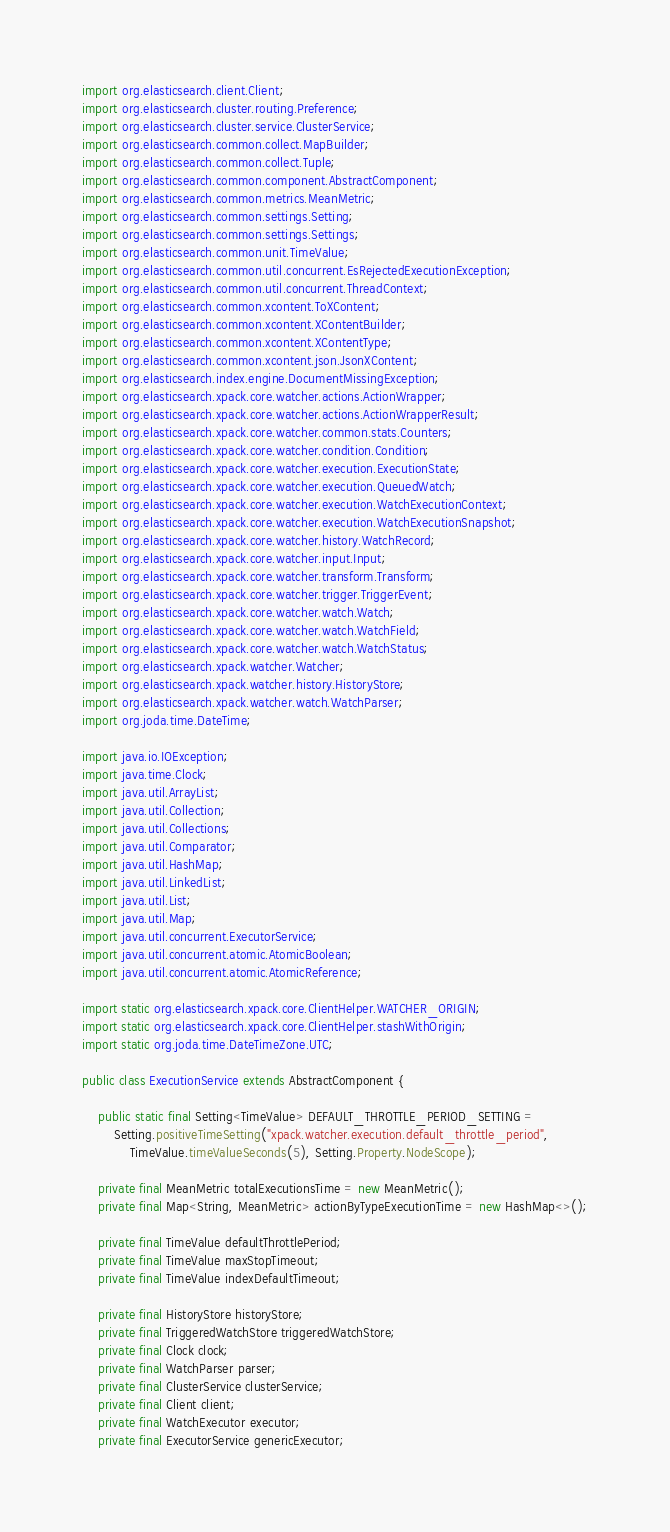Convert code to text. <code><loc_0><loc_0><loc_500><loc_500><_Java_>import org.elasticsearch.client.Client;
import org.elasticsearch.cluster.routing.Preference;
import org.elasticsearch.cluster.service.ClusterService;
import org.elasticsearch.common.collect.MapBuilder;
import org.elasticsearch.common.collect.Tuple;
import org.elasticsearch.common.component.AbstractComponent;
import org.elasticsearch.common.metrics.MeanMetric;
import org.elasticsearch.common.settings.Setting;
import org.elasticsearch.common.settings.Settings;
import org.elasticsearch.common.unit.TimeValue;
import org.elasticsearch.common.util.concurrent.EsRejectedExecutionException;
import org.elasticsearch.common.util.concurrent.ThreadContext;
import org.elasticsearch.common.xcontent.ToXContent;
import org.elasticsearch.common.xcontent.XContentBuilder;
import org.elasticsearch.common.xcontent.XContentType;
import org.elasticsearch.common.xcontent.json.JsonXContent;
import org.elasticsearch.index.engine.DocumentMissingException;
import org.elasticsearch.xpack.core.watcher.actions.ActionWrapper;
import org.elasticsearch.xpack.core.watcher.actions.ActionWrapperResult;
import org.elasticsearch.xpack.core.watcher.common.stats.Counters;
import org.elasticsearch.xpack.core.watcher.condition.Condition;
import org.elasticsearch.xpack.core.watcher.execution.ExecutionState;
import org.elasticsearch.xpack.core.watcher.execution.QueuedWatch;
import org.elasticsearch.xpack.core.watcher.execution.WatchExecutionContext;
import org.elasticsearch.xpack.core.watcher.execution.WatchExecutionSnapshot;
import org.elasticsearch.xpack.core.watcher.history.WatchRecord;
import org.elasticsearch.xpack.core.watcher.input.Input;
import org.elasticsearch.xpack.core.watcher.transform.Transform;
import org.elasticsearch.xpack.core.watcher.trigger.TriggerEvent;
import org.elasticsearch.xpack.core.watcher.watch.Watch;
import org.elasticsearch.xpack.core.watcher.watch.WatchField;
import org.elasticsearch.xpack.core.watcher.watch.WatchStatus;
import org.elasticsearch.xpack.watcher.Watcher;
import org.elasticsearch.xpack.watcher.history.HistoryStore;
import org.elasticsearch.xpack.watcher.watch.WatchParser;
import org.joda.time.DateTime;

import java.io.IOException;
import java.time.Clock;
import java.util.ArrayList;
import java.util.Collection;
import java.util.Collections;
import java.util.Comparator;
import java.util.HashMap;
import java.util.LinkedList;
import java.util.List;
import java.util.Map;
import java.util.concurrent.ExecutorService;
import java.util.concurrent.atomic.AtomicBoolean;
import java.util.concurrent.atomic.AtomicReference;

import static org.elasticsearch.xpack.core.ClientHelper.WATCHER_ORIGIN;
import static org.elasticsearch.xpack.core.ClientHelper.stashWithOrigin;
import static org.joda.time.DateTimeZone.UTC;

public class ExecutionService extends AbstractComponent {

    public static final Setting<TimeValue> DEFAULT_THROTTLE_PERIOD_SETTING =
        Setting.positiveTimeSetting("xpack.watcher.execution.default_throttle_period",
            TimeValue.timeValueSeconds(5), Setting.Property.NodeScope);

    private final MeanMetric totalExecutionsTime = new MeanMetric();
    private final Map<String, MeanMetric> actionByTypeExecutionTime = new HashMap<>();

    private final TimeValue defaultThrottlePeriod;
    private final TimeValue maxStopTimeout;
    private final TimeValue indexDefaultTimeout;

    private final HistoryStore historyStore;
    private final TriggeredWatchStore triggeredWatchStore;
    private final Clock clock;
    private final WatchParser parser;
    private final ClusterService clusterService;
    private final Client client;
    private final WatchExecutor executor;
    private final ExecutorService genericExecutor;
</code> 